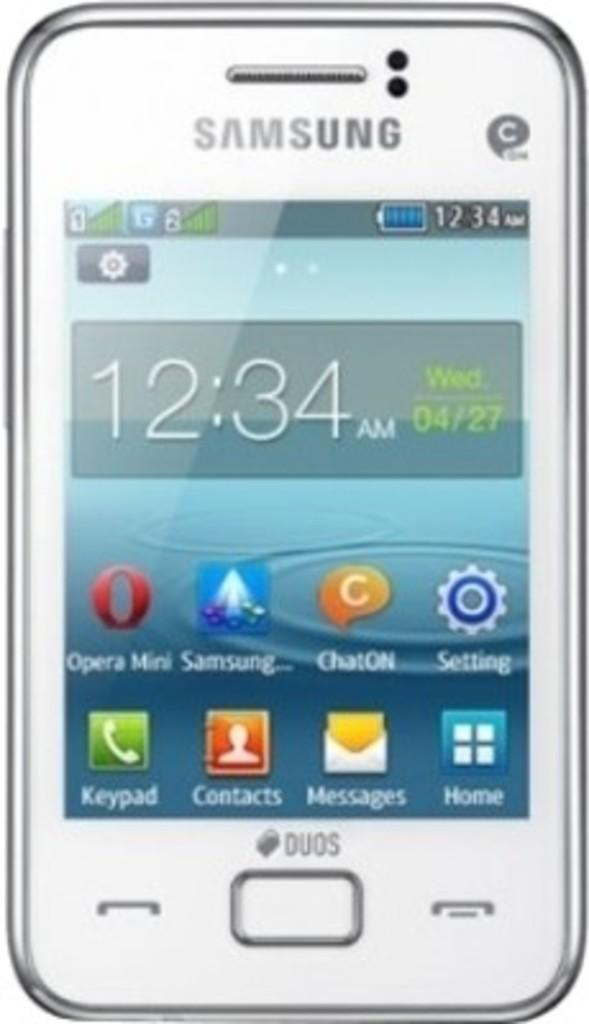<image>
Write a terse but informative summary of the picture. A Samsung phone with the time 12:34 on Wednesday 04/27. 